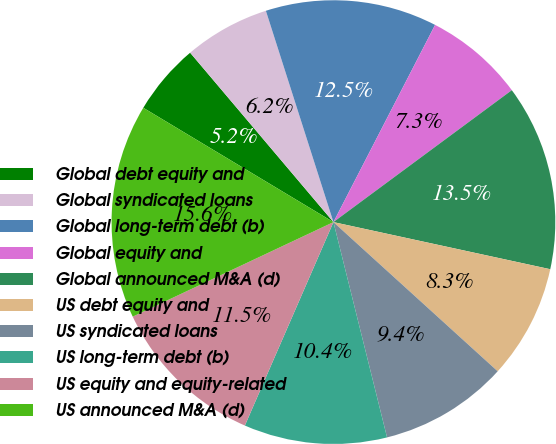Convert chart to OTSL. <chart><loc_0><loc_0><loc_500><loc_500><pie_chart><fcel>Global debt equity and<fcel>Global syndicated loans<fcel>Global long-term debt (b)<fcel>Global equity and<fcel>Global announced M&A (d)<fcel>US debt equity and<fcel>US syndicated loans<fcel>US long-term debt (b)<fcel>US equity and equity-related<fcel>US announced M&A (d)<nl><fcel>5.21%<fcel>6.25%<fcel>12.5%<fcel>7.29%<fcel>13.54%<fcel>8.33%<fcel>9.38%<fcel>10.42%<fcel>11.46%<fcel>15.62%<nl></chart> 